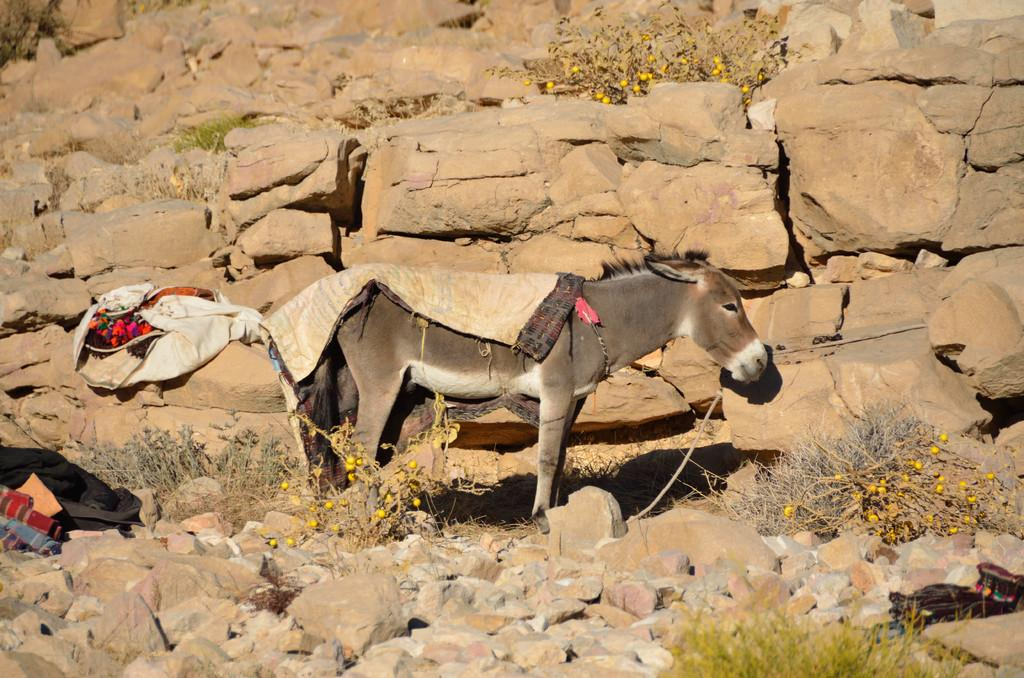Where was the image taken? The image was clicked outside the city. What is the main subject of the image? There is a donkey standing in the center of the image. What is the donkey standing on? The donkey is standing on the ground. What type of natural elements can be seen in the image? There are stones and plants visible in the image. Are there any other objects present in the image besides the donkey? Yes, there are other objects present in the image. What type of popcorn can be seen growing on the plants in the image? There is no popcorn present in the image; the plants are not popcorn plants. What sense is the donkey using to interact with the stones in the image? The image does not provide information about the donkey's senses or its interaction with the stones. 